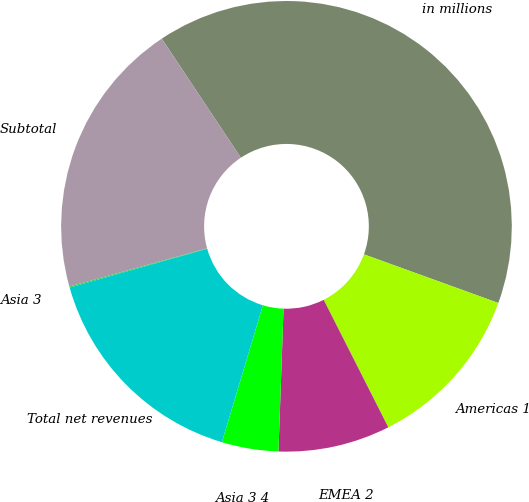Convert chart. <chart><loc_0><loc_0><loc_500><loc_500><pie_chart><fcel>in millions<fcel>Americas 1<fcel>EMEA 2<fcel>Asia 3 4<fcel>Total net revenues<fcel>Asia 3<fcel>Subtotal<nl><fcel>39.86%<fcel>12.01%<fcel>8.03%<fcel>4.06%<fcel>15.99%<fcel>0.08%<fcel>19.97%<nl></chart> 